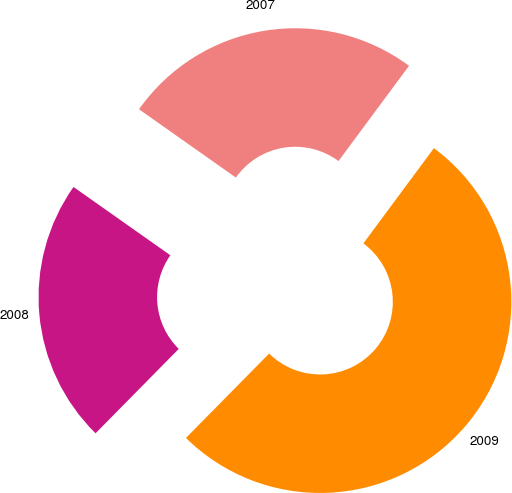<chart> <loc_0><loc_0><loc_500><loc_500><pie_chart><fcel>2009<fcel>2008<fcel>2007<nl><fcel>52.24%<fcel>22.39%<fcel>25.37%<nl></chart> 